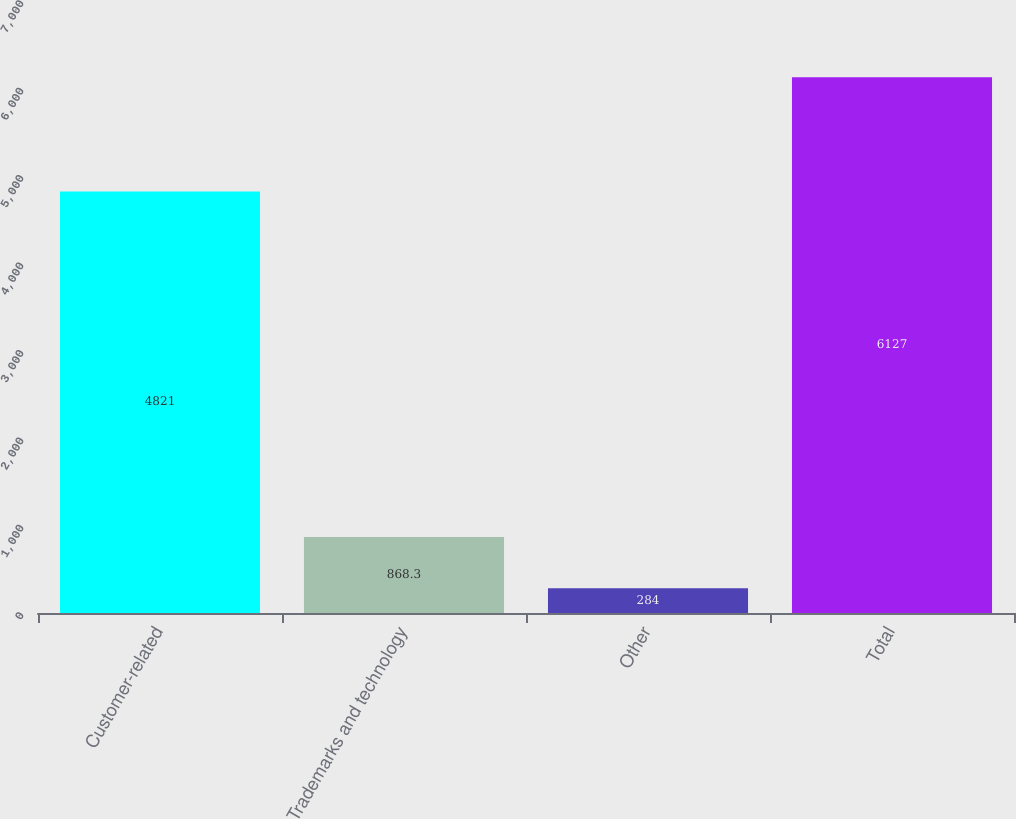Convert chart to OTSL. <chart><loc_0><loc_0><loc_500><loc_500><bar_chart><fcel>Customer-related<fcel>Trademarks and technology<fcel>Other<fcel>Total<nl><fcel>4821<fcel>868.3<fcel>284<fcel>6127<nl></chart> 